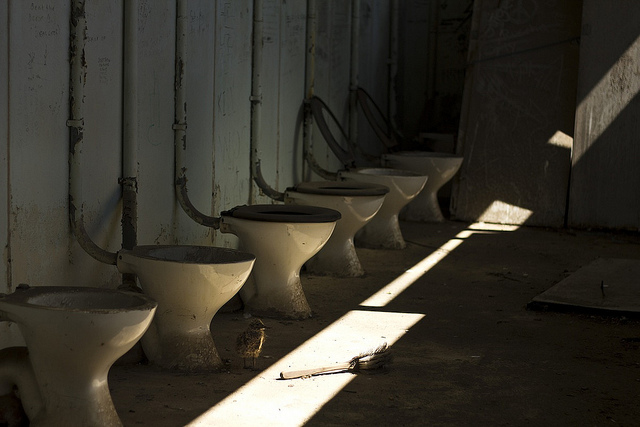<image>What is inside the second toilet? I don't know what is inside the second toilet. It can be water or something else. What is inside the second toilet? I don't know what is inside the second toilet. It can be water, poop, or feces. 